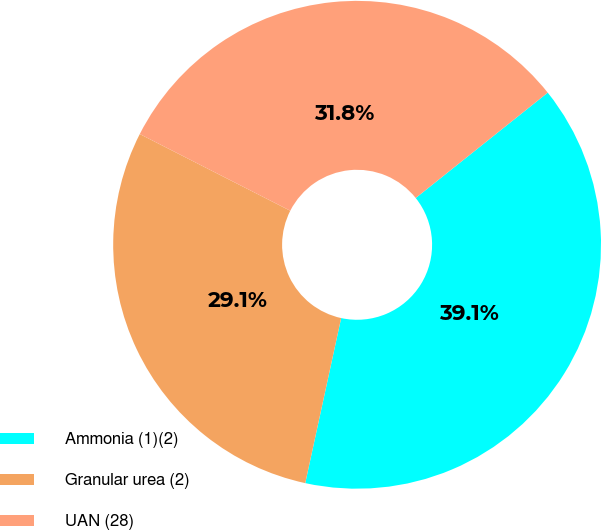Convert chart to OTSL. <chart><loc_0><loc_0><loc_500><loc_500><pie_chart><fcel>Ammonia (1)(2)<fcel>Granular urea (2)<fcel>UAN (28)<nl><fcel>39.13%<fcel>29.09%<fcel>31.78%<nl></chart> 